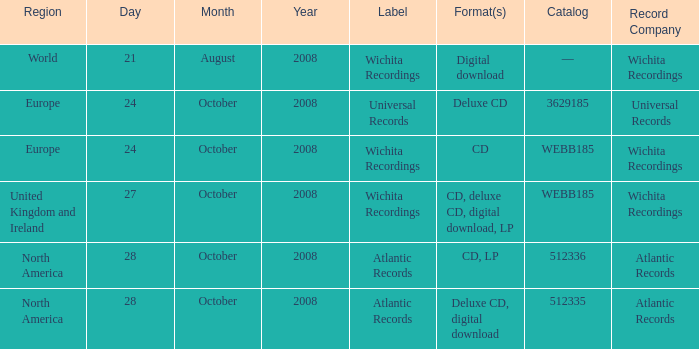What are the formats associated with the Atlantic Records label, catalog number 512336? CD, LP. 